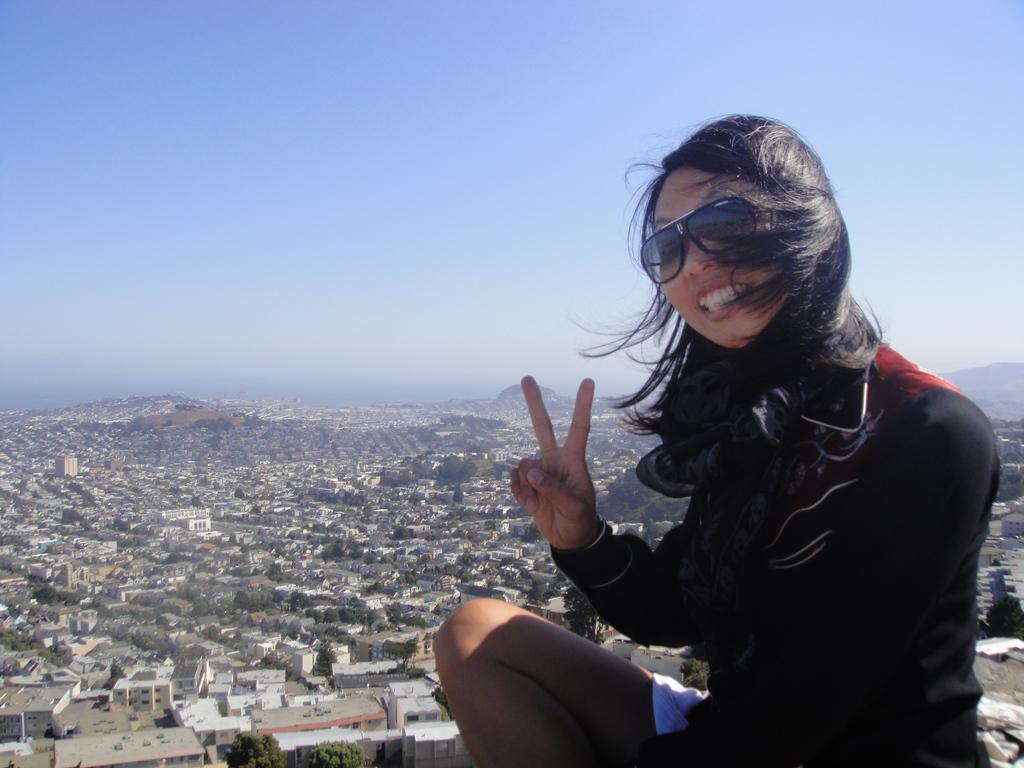Describe this image in one or two sentences. In this image on the right side, I can see a woman. In the background, I can see the buildings, trees and the hills. At the top I can see the sky. 